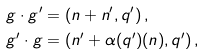<formula> <loc_0><loc_0><loc_500><loc_500>g \cdot g ^ { \prime } & = \left ( n + n ^ { \prime } , q ^ { \prime } \right ) , \\ g ^ { \prime } \cdot g & = \left ( n ^ { \prime } + \alpha ( q ^ { \prime } ) ( n ) , q ^ { \prime } \right ) ,</formula> 